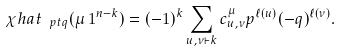Convert formula to latex. <formula><loc_0><loc_0><loc_500><loc_500>\chi h a t _ { \ p t q } ( \mu \, 1 ^ { n - k } ) = ( - 1 ) ^ { k } \sum _ { u , \nu \vdash k } c _ { u , \nu } ^ { \mu } p ^ { \ell ( u ) } ( - q ) ^ { \ell ( \nu ) } .</formula> 